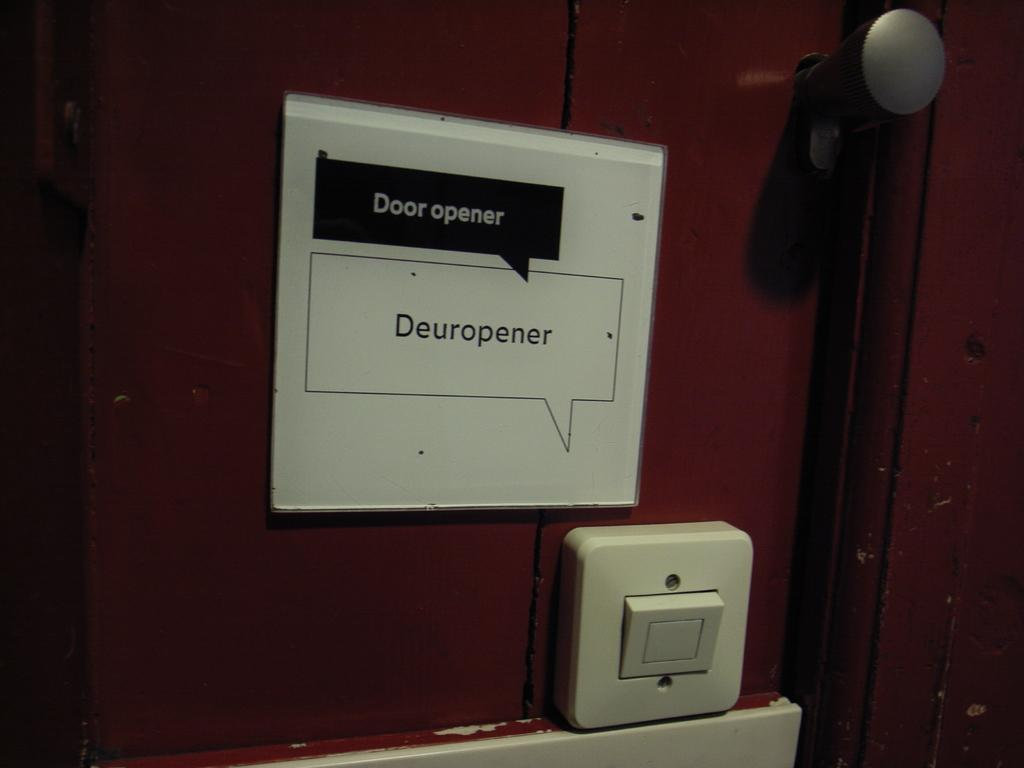<image>
Share a concise interpretation of the image provided. A door with a sign posted above a button on the door that says Door opener above a button. 